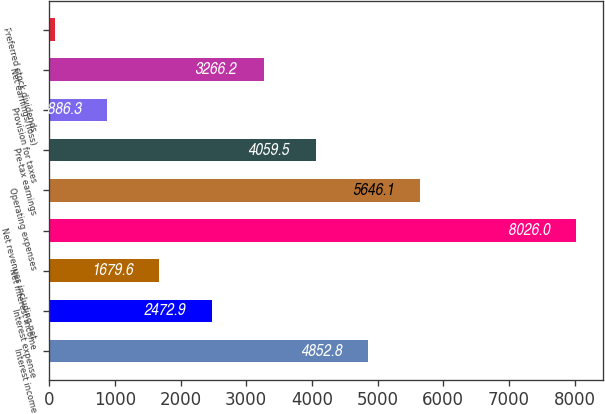Convert chart to OTSL. <chart><loc_0><loc_0><loc_500><loc_500><bar_chart><fcel>Interest income<fcel>Interest expense<fcel>Net interest income<fcel>Net revenues including net<fcel>Operating expenses<fcel>Pre-tax earnings<fcel>Provision for taxes<fcel>Net earnings/(loss)<fcel>Preferred stock dividends<nl><fcel>4852.8<fcel>2472.9<fcel>1679.6<fcel>8026<fcel>5646.1<fcel>4059.5<fcel>886.3<fcel>3266.2<fcel>93<nl></chart> 